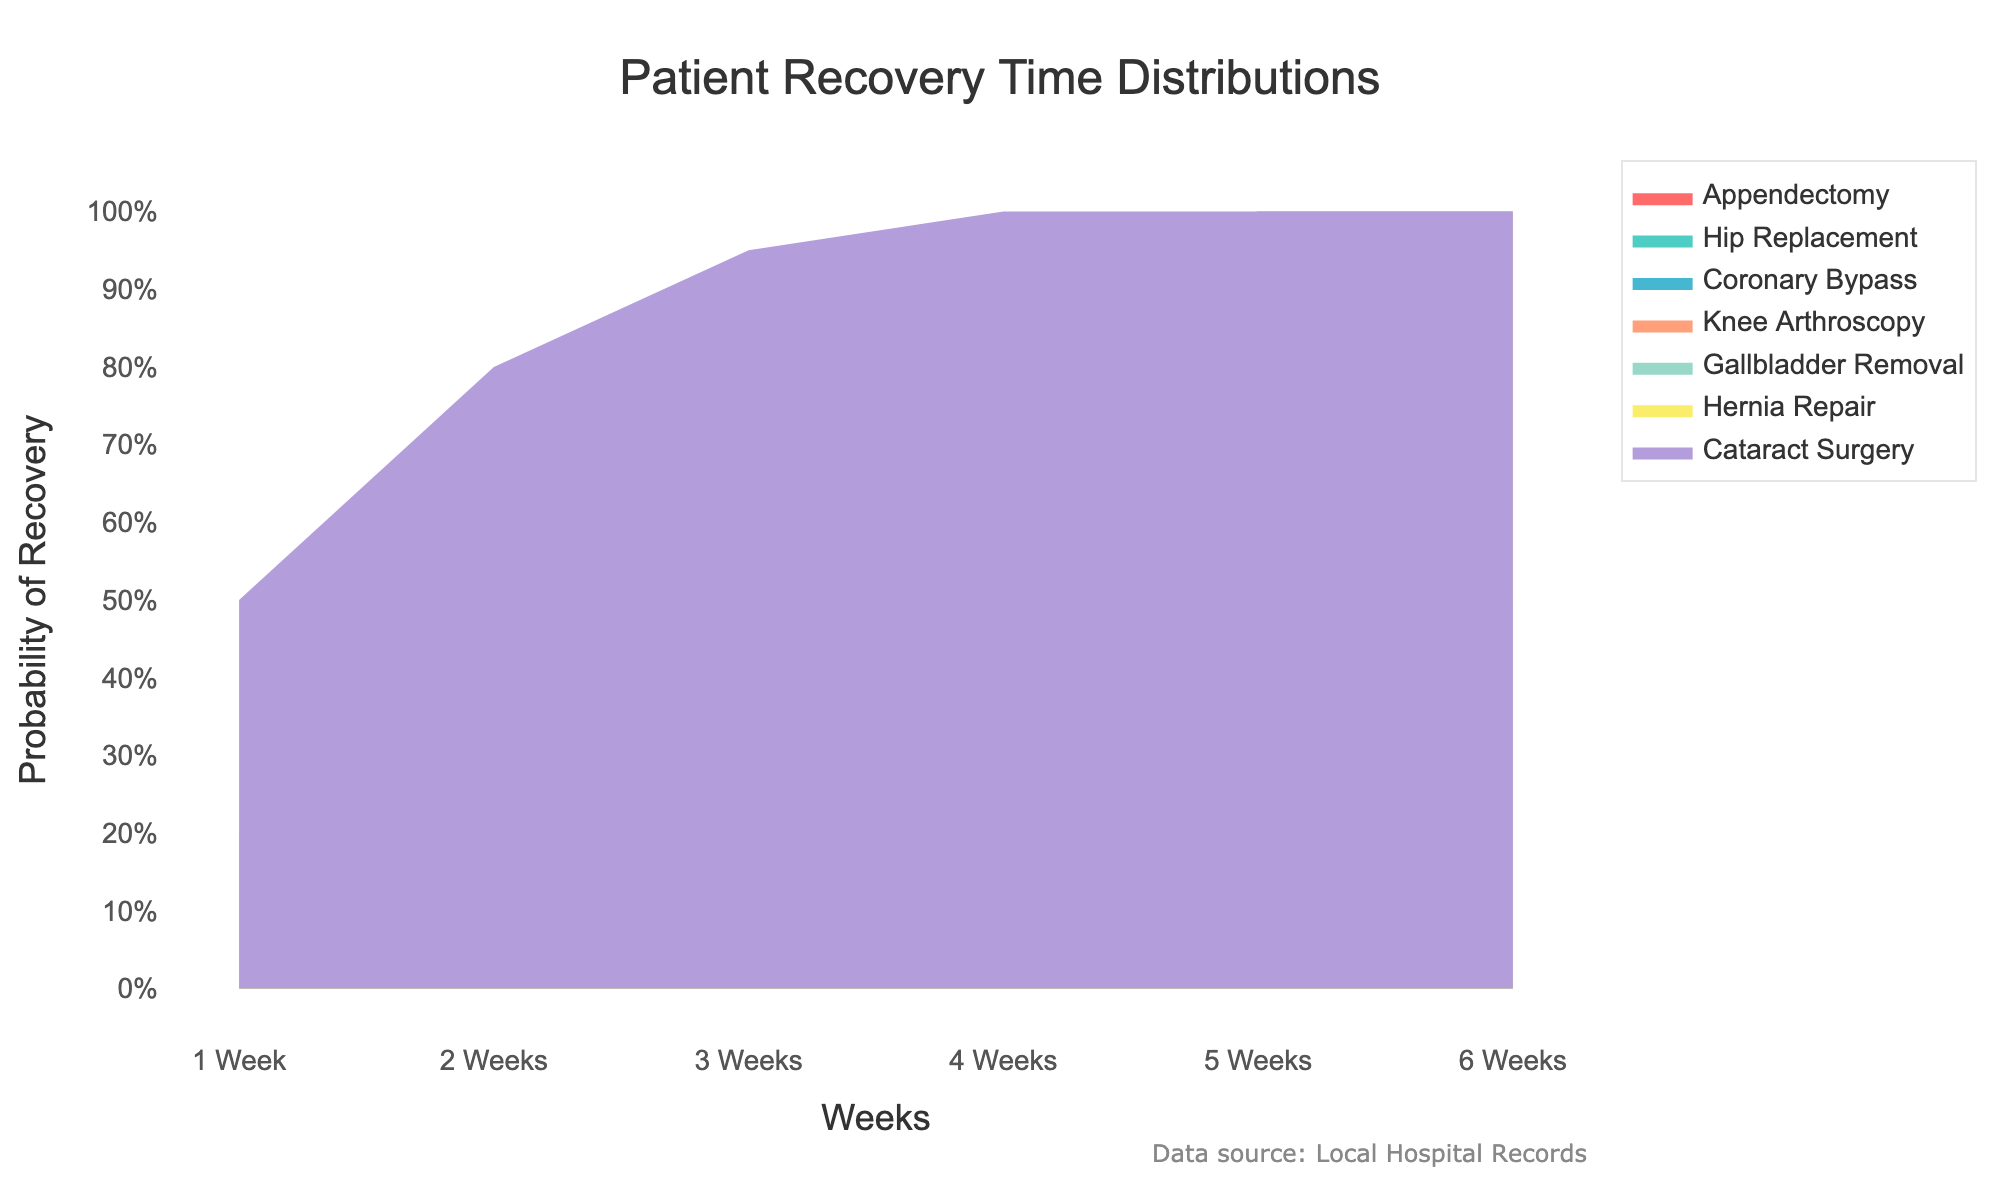What is the title of the chart? The title is displayed at the top of the chart, usually in a larger font for prominence. This particular chart's title directly indicates what it is showing.
Answer: Patient Recovery Time Distributions Which treatment has the highest probability of recovery at 1 week? To find the highest probability, inspect the vertical axis values under the 1-week mark for each treatment and identify the maximum value.
Answer: Cataract Surgery What is the probability of recovery for Hip Replacement after 3 weeks? Locate the point on the Hip Replacement line at the 3-week mark on the horizontal axis and trace it to find the corresponding value on the vertical axis.
Answer: 0.3 How does the recovery probability for Appendectomy after 2 weeks compare to that of Gallbladder Removal? Check the probabilities for both Appendectomy and Gallbladder Removal at the 2-week mark and compare the values directly.
Answer: Appendectomy has a lower probability (0.3 vs. 0.4) Which treatment shows the quickest recovery with a 100% probability within 4 weeks? Find which treatment's recovery probability reaches 1.0 by or before the 4-week mark on the horizontal axis.
Answer: Cataract Surgery At which week does Hernia Repair achieve a 95% recovery probability? Look for the point where the Hernia Repair line reaches a probability of 0.95 on the vertical axis and trace it back to the corresponding week on the horizontal axis.
Answer: 4 Weeks What is the difference in recovery probabilities between Knee Arthroscopy and Coronary Bypass at 5 weeks? Calculate the recovery probabilities for both treatments at the 5-week mark and subtract one from the other. For Knee Arthroscopy, it’s 1.0, and for Coronary Bypass, it’s 0.6.
Answer: 0.4 Which treatment has the lowest probability of recovery after 6 weeks? Check the probability values for all treatments at the 6-week mark and identify the minimum value.
Answer: Coronary Bypass How much earlier does Gallbladder Removal reach a 70% recovery probability compared to Hip Replacement? Determine the weeks at which both treatments hit the 70% probability marks and find the difference: Gallbladder Removal at 3 weeks and Hip Replacement at 5 weeks.
Answer: 2 weeks What can be inferred about the overall recovery time for Cataract Surgery compared to other treatments? Observe the entire distribution of recovery probabilities for Cataract Surgery compared to other treatments to infer that it consistently reaches higher recovery probabilities earlier. Cataract Surgery achieves full recovery the quickest.
Answer: Cataract Surgery has the fastest recovery time 